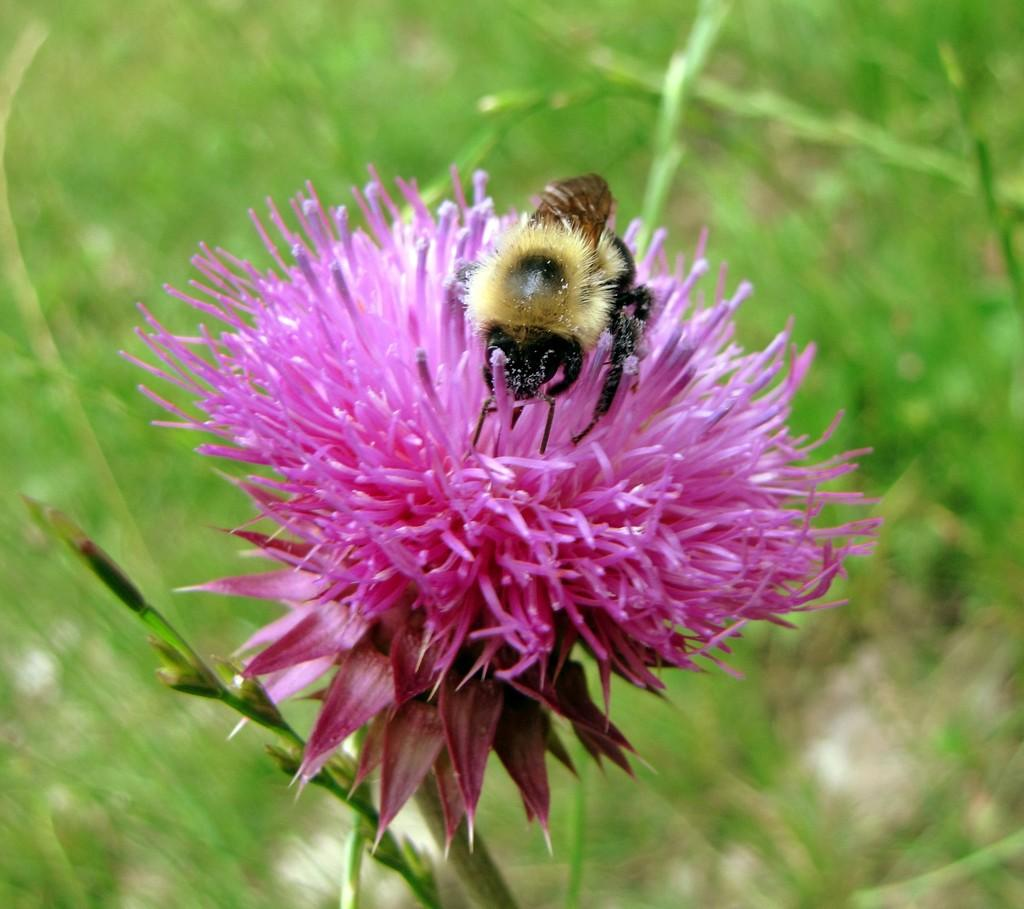What is the main subject in the foreground of the image? There is an insect on a flower in the foreground of the image. Can you describe the flower in the image? The flower is pink and beautiful. What can be seen in the background of the image? There is grass and a plant in the background of the image. What type of bulb is used to light up the prison in the image? There is no prison or bulb present in the image; it features an insect on a flower with a background of grass and a plant. 